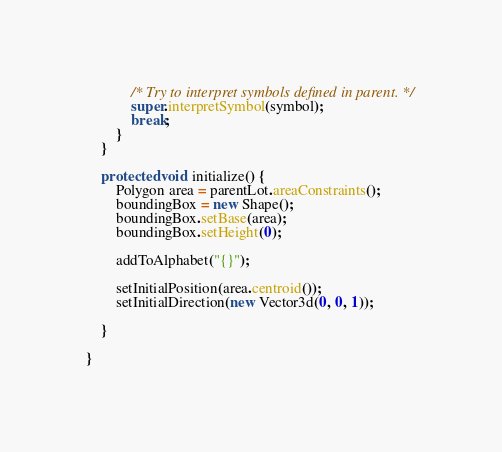Convert code to text. <code><loc_0><loc_0><loc_500><loc_500><_Java_>			/* Try to interpret symbols defined in parent. */
			super.interpretSymbol(symbol);
			break;
		}
	}

	protected void initialize() {
		Polygon area = parentLot.areaConstraints();
		boundingBox = new Shape();
		boundingBox.setBase(area);
		boundingBox.setHeight(0);

		addToAlphabet("{}");

		setInitialPosition(area.centroid());
		setInitialDirection(new Vector3d(0, 0, 1));

	}

}
</code> 